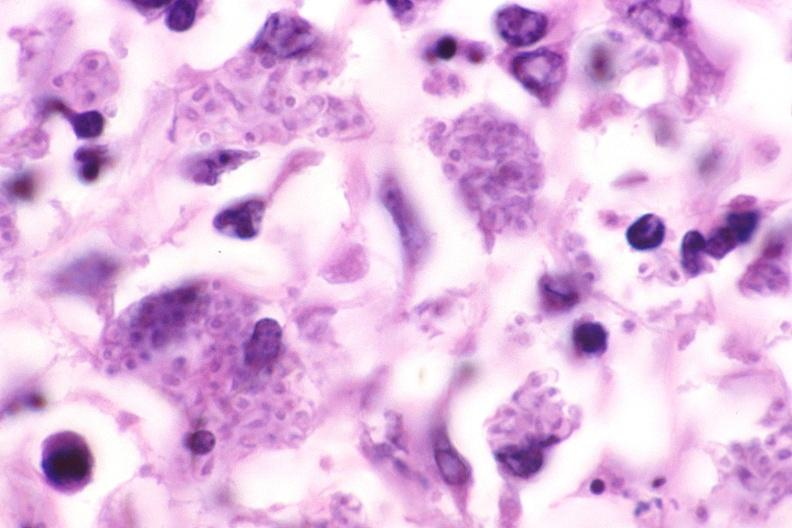what does this image show?
Answer the question using a single word or phrase. Lung 